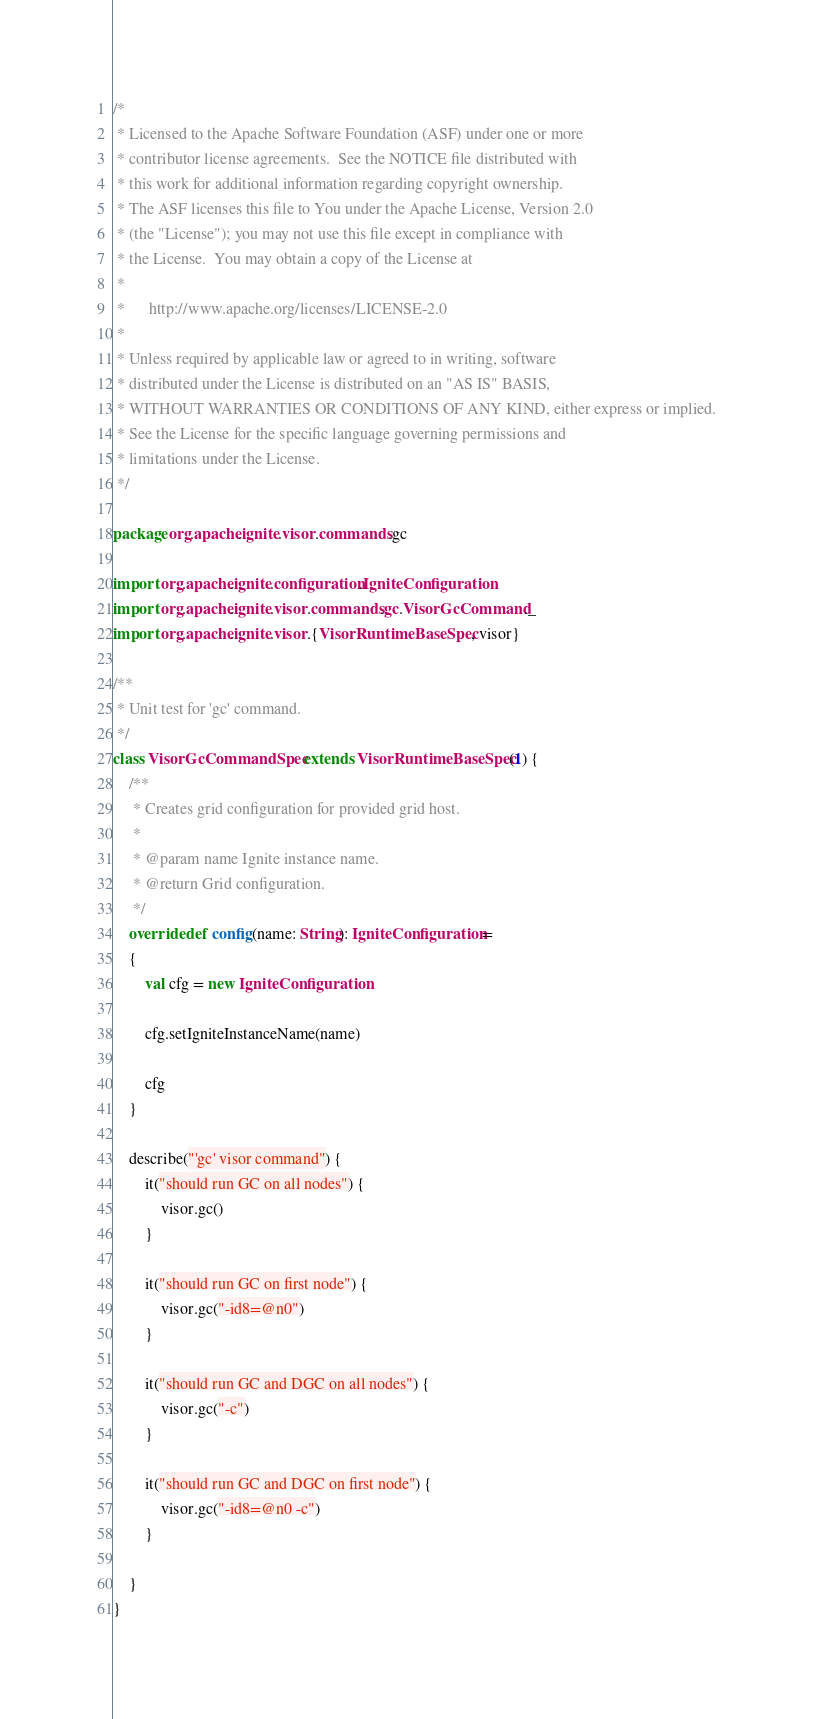<code> <loc_0><loc_0><loc_500><loc_500><_Scala_>/*
 * Licensed to the Apache Software Foundation (ASF) under one or more
 * contributor license agreements.  See the NOTICE file distributed with
 * this work for additional information regarding copyright ownership.
 * The ASF licenses this file to You under the Apache License, Version 2.0
 * (the "License"); you may not use this file except in compliance with
 * the License.  You may obtain a copy of the License at
 *
 *      http://www.apache.org/licenses/LICENSE-2.0
 *
 * Unless required by applicable law or agreed to in writing, software
 * distributed under the License is distributed on an "AS IS" BASIS,
 * WITHOUT WARRANTIES OR CONDITIONS OF ANY KIND, either express or implied.
 * See the License for the specific language governing permissions and
 * limitations under the License.
 */

package org.apache.ignite.visor.commands.gc

import org.apache.ignite.configuration.IgniteConfiguration
import org.apache.ignite.visor.commands.gc.VisorGcCommand._
import org.apache.ignite.visor.{VisorRuntimeBaseSpec, visor}

/**
 * Unit test for 'gc' command.
 */
class VisorGcCommandSpec extends VisorRuntimeBaseSpec(1) {
    /**
     * Creates grid configuration for provided grid host.
     *
     * @param name Ignite instance name.
     * @return Grid configuration.
     */
    override def config(name: String): IgniteConfiguration =
    {
        val cfg = new IgniteConfiguration

        cfg.setIgniteInstanceName(name)

        cfg
    }

    describe("'gc' visor command") {
        it("should run GC on all nodes") {
            visor.gc()
        }

        it("should run GC on first node") {
            visor.gc("-id8=@n0")
        }

        it("should run GC and DGC on all nodes") {
            visor.gc("-c")
        }

        it("should run GC and DGC on first node") {
            visor.gc("-id8=@n0 -c")
        }

    }
}
</code> 